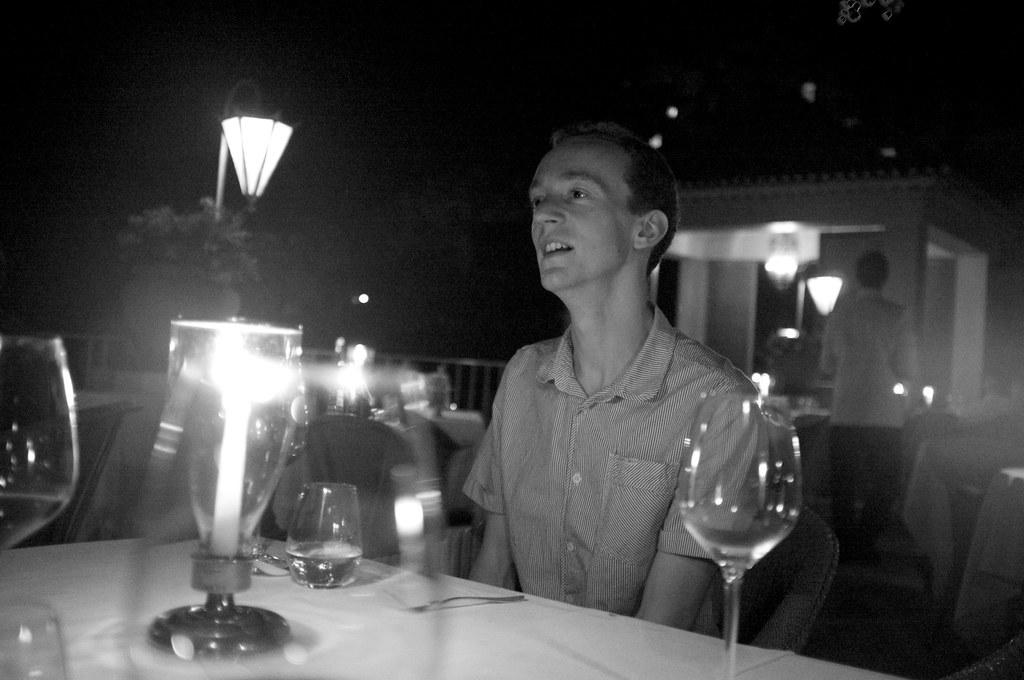What is the man in the image doing? The man is sitting on a chair in the image. What is located behind the man? The man is in front of a table in the image. What object provides light in the image? There is a lamp in the image. What type of vegetation can be seen in the image? There is a tree in the image. Can you describe another person's action in the image? There is a man walking in the image. What type of lettuce is being used as a hat by the man walking in the image? There is no lettuce present in the image, and the man walking is not wearing a hat. 